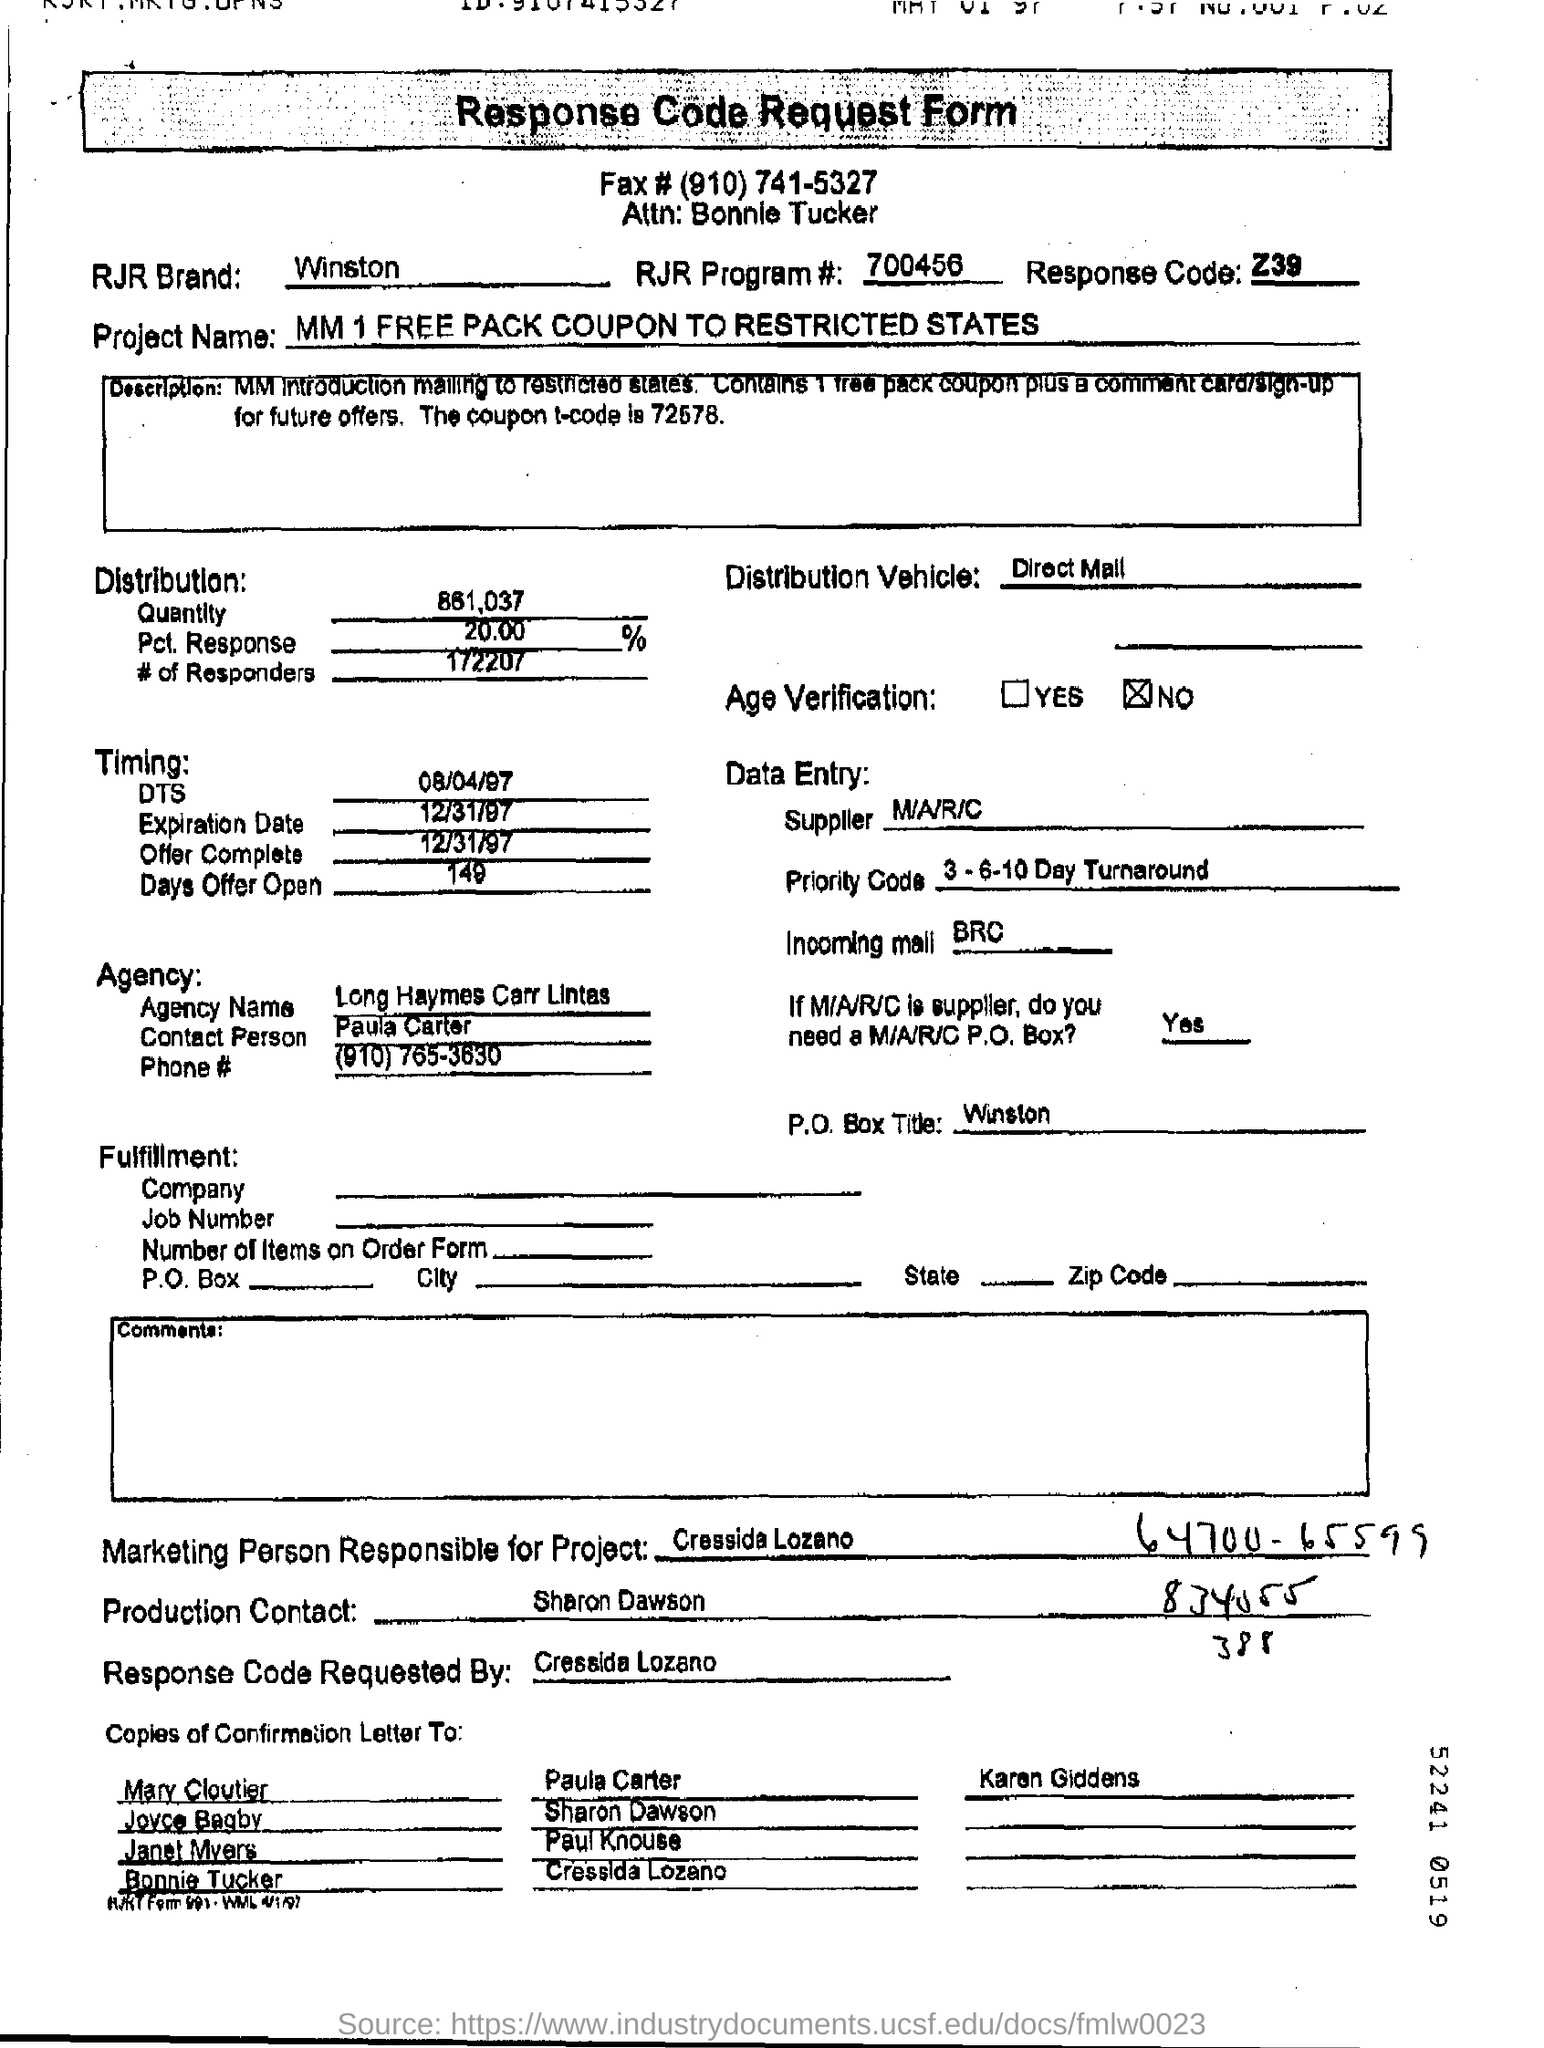What is the rjr brand?
Your response must be concise. Winston. Is there age verification ?
Make the answer very short. No. What is the rjr brand?
Your response must be concise. Winston. What is time of dts?
Offer a terse response. 08/04/97. Who is supplier?
Your answer should be compact. M/A/R/C. 